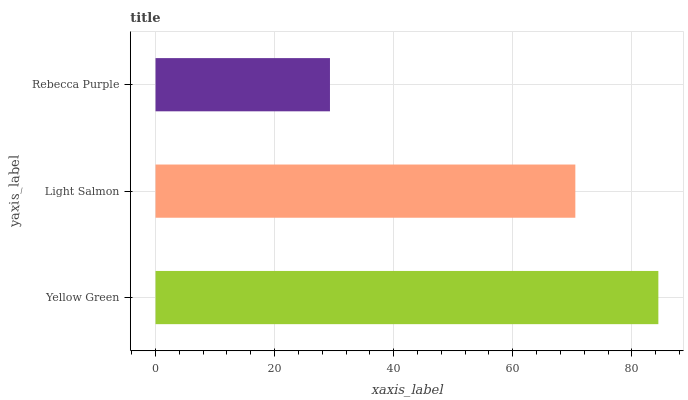Is Rebecca Purple the minimum?
Answer yes or no. Yes. Is Yellow Green the maximum?
Answer yes or no. Yes. Is Light Salmon the minimum?
Answer yes or no. No. Is Light Salmon the maximum?
Answer yes or no. No. Is Yellow Green greater than Light Salmon?
Answer yes or no. Yes. Is Light Salmon less than Yellow Green?
Answer yes or no. Yes. Is Light Salmon greater than Yellow Green?
Answer yes or no. No. Is Yellow Green less than Light Salmon?
Answer yes or no. No. Is Light Salmon the high median?
Answer yes or no. Yes. Is Light Salmon the low median?
Answer yes or no. Yes. Is Rebecca Purple the high median?
Answer yes or no. No. Is Yellow Green the low median?
Answer yes or no. No. 